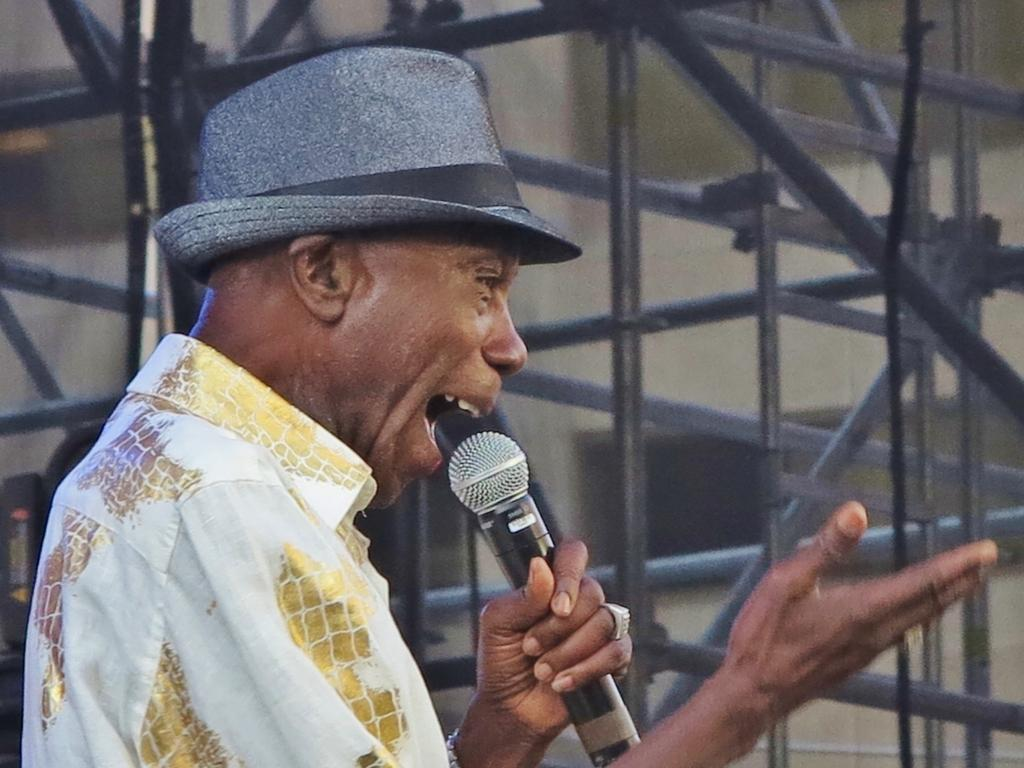Who is the main subject in the image? There is a man in the image. What is the man doing in the image? The man is talking on a mike. Can you describe the man's attire in the image? The man is wearing a cap. What type of plantation can be seen in the background of the image? There is no plantation visible in the image; it only features a man talking on a mike while wearing a cap. 